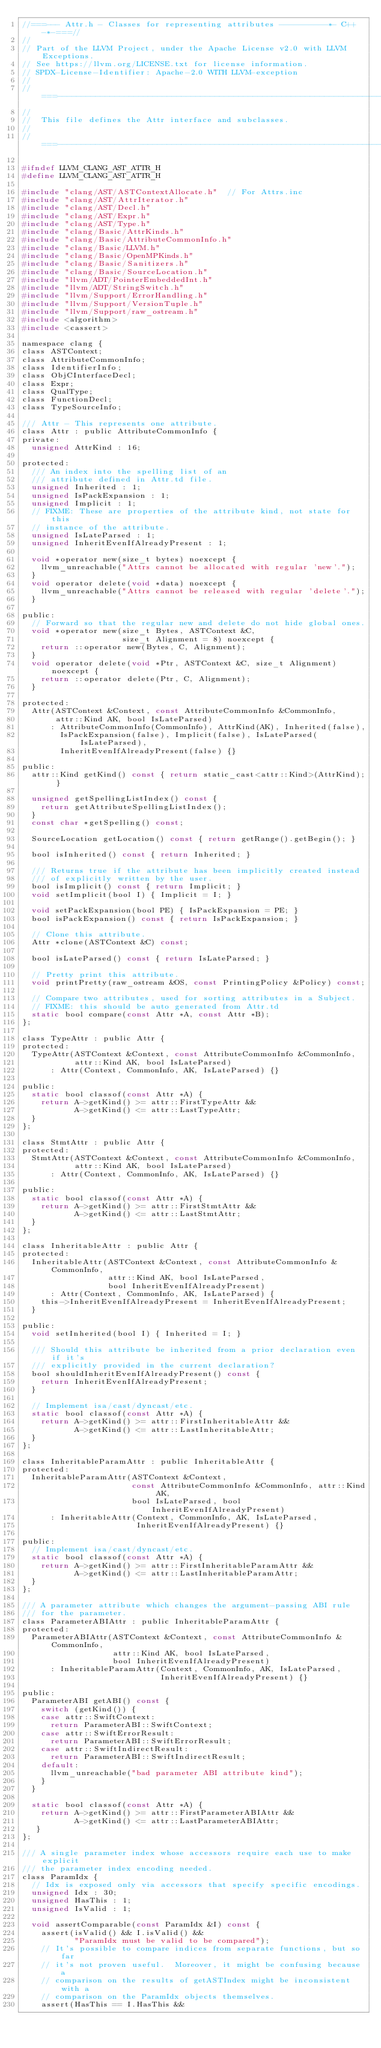Convert code to text. <code><loc_0><loc_0><loc_500><loc_500><_C_>//===--- Attr.h - Classes for representing attributes ----------*- C++ -*-===//
//
// Part of the LLVM Project, under the Apache License v2.0 with LLVM Exceptions.
// See https://llvm.org/LICENSE.txt for license information.
// SPDX-License-Identifier: Apache-2.0 WITH LLVM-exception
//
//===----------------------------------------------------------------------===//
//
//  This file defines the Attr interface and subclasses.
//
//===----------------------------------------------------------------------===//

#ifndef LLVM_CLANG_AST_ATTR_H
#define LLVM_CLANG_AST_ATTR_H

#include "clang/AST/ASTContextAllocate.h"  // For Attrs.inc
#include "clang/AST/AttrIterator.h"
#include "clang/AST/Decl.h"
#include "clang/AST/Expr.h"
#include "clang/AST/Type.h"
#include "clang/Basic/AttrKinds.h"
#include "clang/Basic/AttributeCommonInfo.h"
#include "clang/Basic/LLVM.h"
#include "clang/Basic/OpenMPKinds.h"
#include "clang/Basic/Sanitizers.h"
#include "clang/Basic/SourceLocation.h"
#include "llvm/ADT/PointerEmbeddedInt.h"
#include "llvm/ADT/StringSwitch.h"
#include "llvm/Support/ErrorHandling.h"
#include "llvm/Support/VersionTuple.h"
#include "llvm/Support/raw_ostream.h"
#include <algorithm>
#include <cassert>

namespace clang {
class ASTContext;
class AttributeCommonInfo;
class IdentifierInfo;
class ObjCInterfaceDecl;
class Expr;
class QualType;
class FunctionDecl;
class TypeSourceInfo;

/// Attr - This represents one attribute.
class Attr : public AttributeCommonInfo {
private:
  unsigned AttrKind : 16;

protected:
  /// An index into the spelling list of an
  /// attribute defined in Attr.td file.
  unsigned Inherited : 1;
  unsigned IsPackExpansion : 1;
  unsigned Implicit : 1;
  // FIXME: These are properties of the attribute kind, not state for this
  // instance of the attribute.
  unsigned IsLateParsed : 1;
  unsigned InheritEvenIfAlreadyPresent : 1;

  void *operator new(size_t bytes) noexcept {
    llvm_unreachable("Attrs cannot be allocated with regular 'new'.");
  }
  void operator delete(void *data) noexcept {
    llvm_unreachable("Attrs cannot be released with regular 'delete'.");
  }

public:
  // Forward so that the regular new and delete do not hide global ones.
  void *operator new(size_t Bytes, ASTContext &C,
                     size_t Alignment = 8) noexcept {
    return ::operator new(Bytes, C, Alignment);
  }
  void operator delete(void *Ptr, ASTContext &C, size_t Alignment) noexcept {
    return ::operator delete(Ptr, C, Alignment);
  }

protected:
  Attr(ASTContext &Context, const AttributeCommonInfo &CommonInfo,
       attr::Kind AK, bool IsLateParsed)
      : AttributeCommonInfo(CommonInfo), AttrKind(AK), Inherited(false),
        IsPackExpansion(false), Implicit(false), IsLateParsed(IsLateParsed),
        InheritEvenIfAlreadyPresent(false) {}

public:
  attr::Kind getKind() const { return static_cast<attr::Kind>(AttrKind); }

  unsigned getSpellingListIndex() const {
    return getAttributeSpellingListIndex();
  }
  const char *getSpelling() const;

  SourceLocation getLocation() const { return getRange().getBegin(); }

  bool isInherited() const { return Inherited; }

  /// Returns true if the attribute has been implicitly created instead
  /// of explicitly written by the user.
  bool isImplicit() const { return Implicit; }
  void setImplicit(bool I) { Implicit = I; }

  void setPackExpansion(bool PE) { IsPackExpansion = PE; }
  bool isPackExpansion() const { return IsPackExpansion; }

  // Clone this attribute.
  Attr *clone(ASTContext &C) const;

  bool isLateParsed() const { return IsLateParsed; }

  // Pretty print this attribute.
  void printPretty(raw_ostream &OS, const PrintingPolicy &Policy) const;

  // Compare two attributes, used for sorting attributes in a Subject.
  // FIXME: this should be auto generated from Attr.td
  static bool compare(const Attr *A, const Attr *B);
};

class TypeAttr : public Attr {
protected:
  TypeAttr(ASTContext &Context, const AttributeCommonInfo &CommonInfo,
           attr::Kind AK, bool IsLateParsed)
      : Attr(Context, CommonInfo, AK, IsLateParsed) {}

public:
  static bool classof(const Attr *A) {
    return A->getKind() >= attr::FirstTypeAttr &&
           A->getKind() <= attr::LastTypeAttr;
  }
};

class StmtAttr : public Attr {
protected:
  StmtAttr(ASTContext &Context, const AttributeCommonInfo &CommonInfo,
           attr::Kind AK, bool IsLateParsed)
      : Attr(Context, CommonInfo, AK, IsLateParsed) {}

public:
  static bool classof(const Attr *A) {
    return A->getKind() >= attr::FirstStmtAttr &&
           A->getKind() <= attr::LastStmtAttr;
  }
};

class InheritableAttr : public Attr {
protected:
  InheritableAttr(ASTContext &Context, const AttributeCommonInfo &CommonInfo,
                  attr::Kind AK, bool IsLateParsed,
                  bool InheritEvenIfAlreadyPresent)
      : Attr(Context, CommonInfo, AK, IsLateParsed) {
    this->InheritEvenIfAlreadyPresent = InheritEvenIfAlreadyPresent;
  }

public:
  void setInherited(bool I) { Inherited = I; }

  /// Should this attribute be inherited from a prior declaration even if it's
  /// explicitly provided in the current declaration?
  bool shouldInheritEvenIfAlreadyPresent() const {
    return InheritEvenIfAlreadyPresent;
  }

  // Implement isa/cast/dyncast/etc.
  static bool classof(const Attr *A) {
    return A->getKind() >= attr::FirstInheritableAttr &&
           A->getKind() <= attr::LastInheritableAttr;
  }
};

class InheritableParamAttr : public InheritableAttr {
protected:
  InheritableParamAttr(ASTContext &Context,
                       const AttributeCommonInfo &CommonInfo, attr::Kind AK,
                       bool IsLateParsed, bool InheritEvenIfAlreadyPresent)
      : InheritableAttr(Context, CommonInfo, AK, IsLateParsed,
                        InheritEvenIfAlreadyPresent) {}

public:
  // Implement isa/cast/dyncast/etc.
  static bool classof(const Attr *A) {
    return A->getKind() >= attr::FirstInheritableParamAttr &&
           A->getKind() <= attr::LastInheritableParamAttr;
  }
};

/// A parameter attribute which changes the argument-passing ABI rule
/// for the parameter.
class ParameterABIAttr : public InheritableParamAttr {
protected:
  ParameterABIAttr(ASTContext &Context, const AttributeCommonInfo &CommonInfo,
                   attr::Kind AK, bool IsLateParsed,
                   bool InheritEvenIfAlreadyPresent)
      : InheritableParamAttr(Context, CommonInfo, AK, IsLateParsed,
                             InheritEvenIfAlreadyPresent) {}

public:
  ParameterABI getABI() const {
    switch (getKind()) {
    case attr::SwiftContext:
      return ParameterABI::SwiftContext;
    case attr::SwiftErrorResult:
      return ParameterABI::SwiftErrorResult;
    case attr::SwiftIndirectResult:
      return ParameterABI::SwiftIndirectResult;
    default:
      llvm_unreachable("bad parameter ABI attribute kind");
    }
  }

  static bool classof(const Attr *A) {
    return A->getKind() >= attr::FirstParameterABIAttr &&
           A->getKind() <= attr::LastParameterABIAttr;
   }
};

/// A single parameter index whose accessors require each use to make explicit
/// the parameter index encoding needed.
class ParamIdx {
  // Idx is exposed only via accessors that specify specific encodings.
  unsigned Idx : 30;
  unsigned HasThis : 1;
  unsigned IsValid : 1;

  void assertComparable(const ParamIdx &I) const {
    assert(isValid() && I.isValid() &&
           "ParamIdx must be valid to be compared");
    // It's possible to compare indices from separate functions, but so far
    // it's not proven useful.  Moreover, it might be confusing because a
    // comparison on the results of getASTIndex might be inconsistent with a
    // comparison on the ParamIdx objects themselves.
    assert(HasThis == I.HasThis &&</code> 